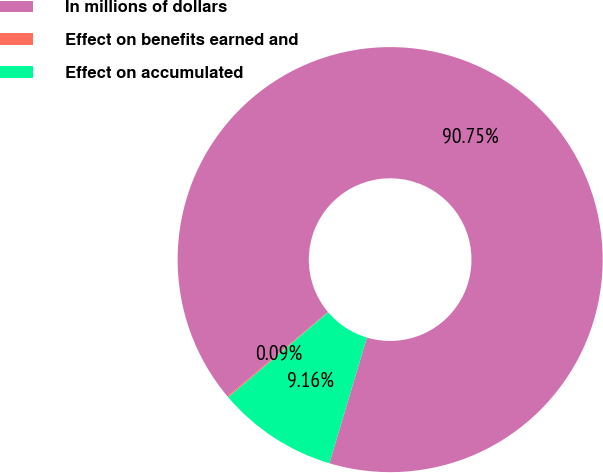<chart> <loc_0><loc_0><loc_500><loc_500><pie_chart><fcel>In millions of dollars<fcel>Effect on benefits earned and<fcel>Effect on accumulated<nl><fcel>90.75%<fcel>0.09%<fcel>9.16%<nl></chart> 